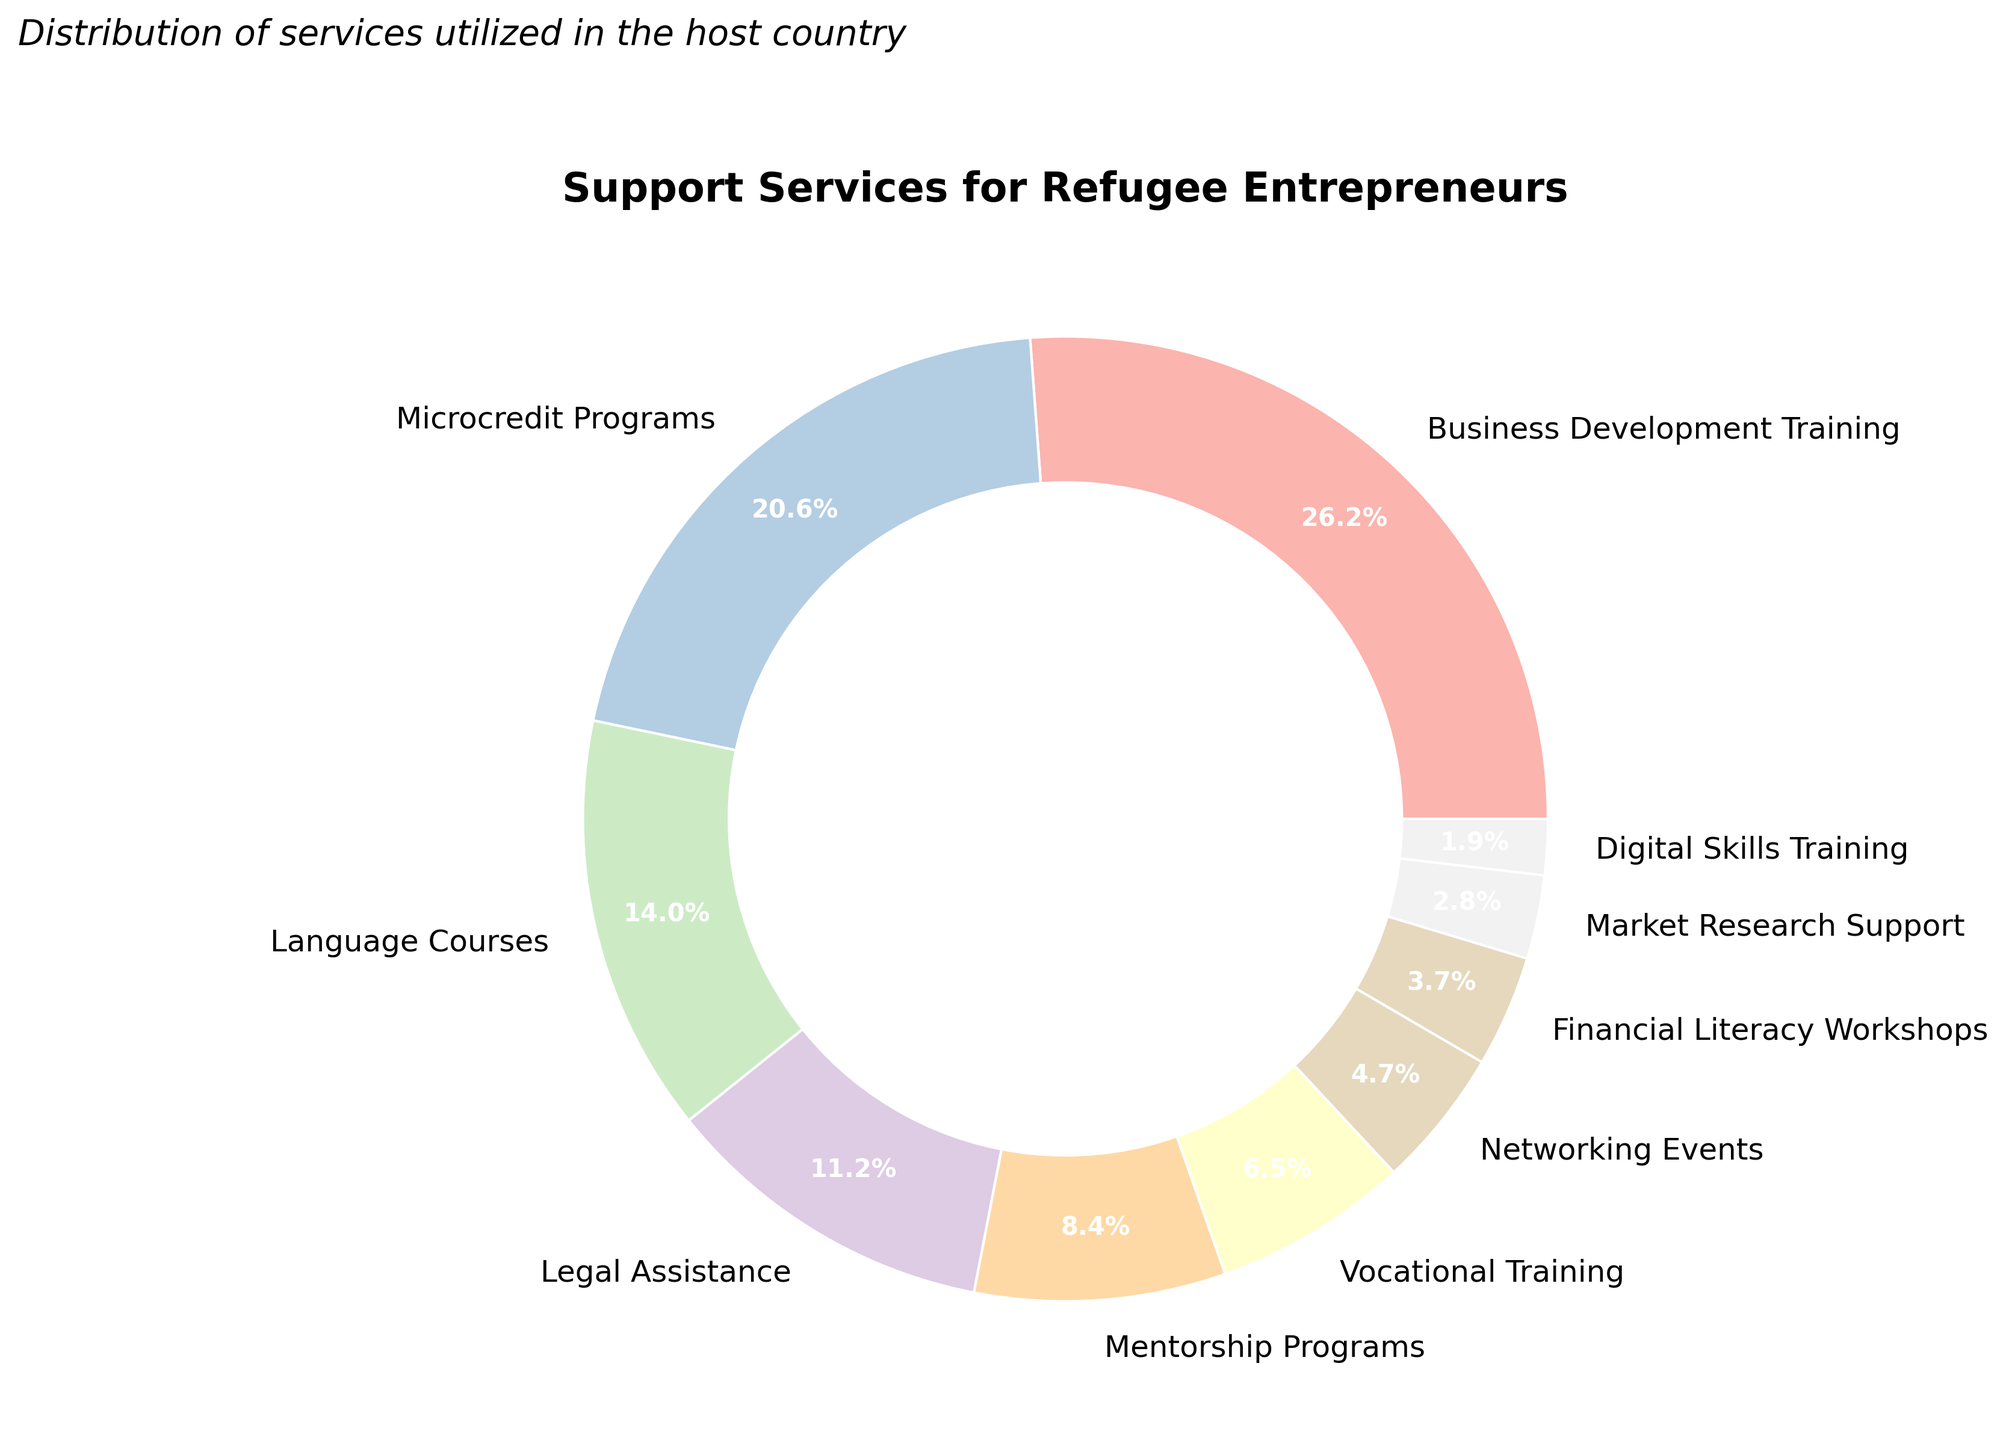What are the two most utilized support services by refugee entrepreneurs? According to the pie chart, the two largest portions represent Business Development Training and Microcredit Programs.
Answer: Business Development Training and Microcredit Programs Which service is utilized more: Language Courses or Legal Assistance? Comparing the two slices, Language Courses has a larger portion than Legal Assistance.
Answer: Language Courses What is the total percentage of services related to training (Business Development Training, Vocational Training, and Digital Skills Training)? Sum the percentages of Business Development Training (28%), Vocational Training (7%), and Digital Skills Training (2%). The total is 28 + 7 + 2 = 37.
Answer: 37% How many times higher is the usage of Business Development Training compared to Digital Skills Training? The percentage for Business Development Training is 28%, while for Digital Skills Training it is 2%. Divide 28 by 2 to get the ratio.
Answer: 14 times Which service ranks fourth in terms of utilization percentage? The fourth largest slice in the chart represents Legal Assistance with 12%.
Answer: Legal Assistance Which services combined make up less than 10% of the total utilization? The services that make up less than 10% are Financial Literacy Workshops, Market Research Support, and Digital Skills Training. Sum their percentages: 4% + 3% + 2% = 9%.
Answer: Financial Literacy Workshops, Market Research Support, and Digital Skills Training How much more frequently is Business Development Training utilized compared to Networking Events? The slice representing Business Development Training is 28%, and Networking Events is 5%. Subtract the percentages: 28 - 5 = 23.
Answer: 23% If we combine the percentages of Mentorship Programs and Networking Events, does their total exceed that of Language Courses? Mentorship Programs is 9% and Networking Events is 5%. Their combined total is 9 + 5 = 14%, which is less than Language Courses at 15%.
Answer: No What percentage of the services are not related to formal education (excluding Business Development Training, Language Courses, Vocational Training, and Digital Skills Training)? Subtract the percentages of formal education-related services from 100%: 100 - (28 + 15 + 7 + 2) = 48%.
Answer: 48% Which service has the smallest utilization percentage, and what is that percentage? The smallest slice on the chart represents Digital Skills Training, which is 2%.
Answer: Digital Skills Training, 2% 